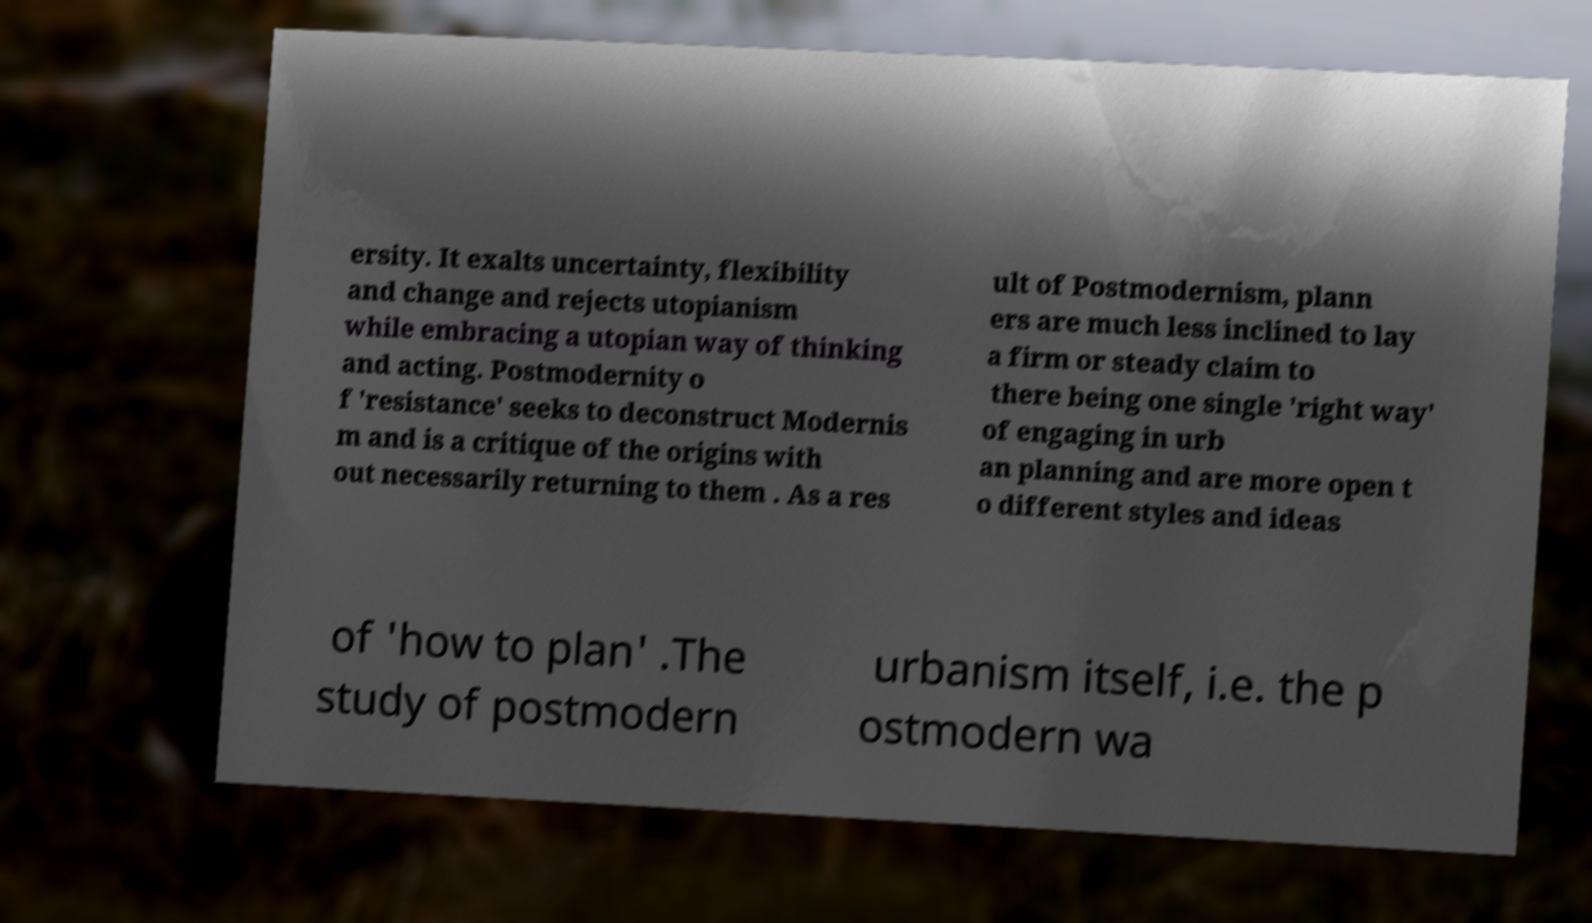Can you read and provide the text displayed in the image?This photo seems to have some interesting text. Can you extract and type it out for me? ersity. It exalts uncertainty, flexibility and change and rejects utopianism while embracing a utopian way of thinking and acting. Postmodernity o f 'resistance' seeks to deconstruct Modernis m and is a critique of the origins with out necessarily returning to them . As a res ult of Postmodernism, plann ers are much less inclined to lay a firm or steady claim to there being one single 'right way' of engaging in urb an planning and are more open t o different styles and ideas of 'how to plan' .The study of postmodern urbanism itself, i.e. the p ostmodern wa 